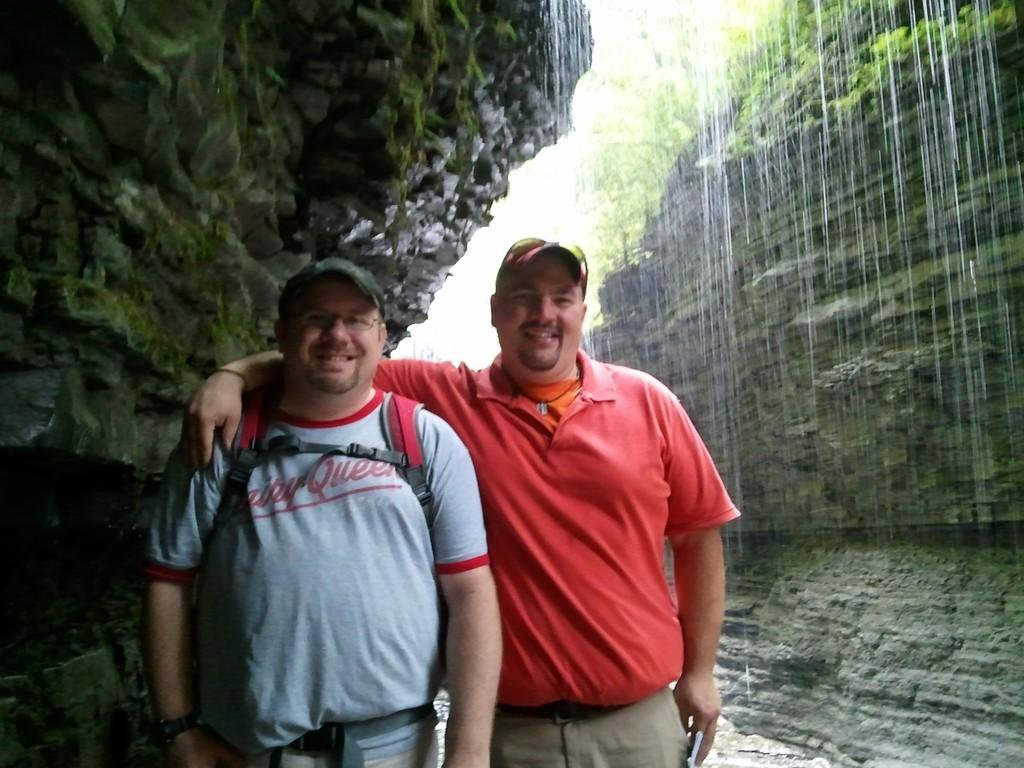<image>
Write a terse but informative summary of the picture. a friend with a tshirt from Dairy Queen stands with a friend in front of a waterfall 